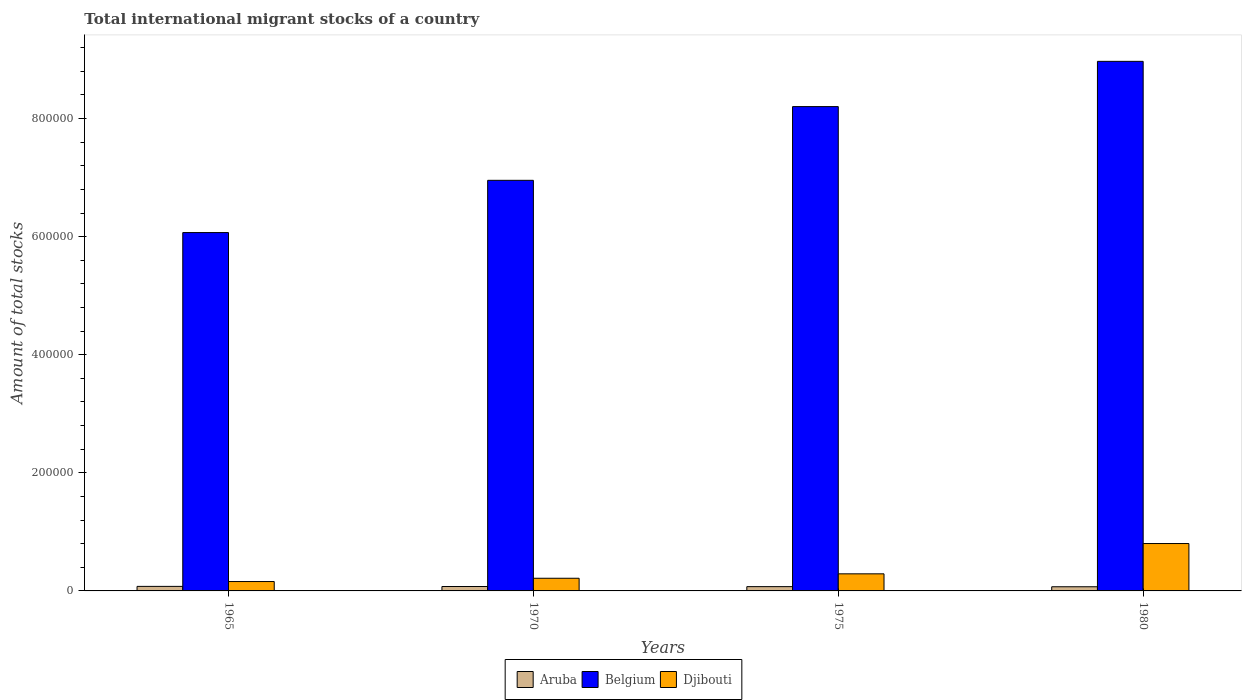Are the number of bars per tick equal to the number of legend labels?
Ensure brevity in your answer.  Yes. Are the number of bars on each tick of the X-axis equal?
Your answer should be very brief. Yes. In how many cases, is the number of bars for a given year not equal to the number of legend labels?
Make the answer very short. 0. What is the amount of total stocks in in Belgium in 1965?
Your answer should be very brief. 6.07e+05. Across all years, what is the maximum amount of total stocks in in Belgium?
Your response must be concise. 8.97e+05. Across all years, what is the minimum amount of total stocks in in Djibouti?
Your response must be concise. 1.59e+04. In which year was the amount of total stocks in in Aruba maximum?
Give a very brief answer. 1965. In which year was the amount of total stocks in in Aruba minimum?
Offer a terse response. 1980. What is the total amount of total stocks in in Djibouti in the graph?
Provide a short and direct response. 1.46e+05. What is the difference between the amount of total stocks in in Belgium in 1965 and that in 1980?
Your answer should be very brief. -2.90e+05. What is the difference between the amount of total stocks in in Belgium in 1965 and the amount of total stocks in in Djibouti in 1970?
Your answer should be compact. 5.85e+05. What is the average amount of total stocks in in Aruba per year?
Provide a succinct answer. 7367. In the year 1965, what is the difference between the amount of total stocks in in Belgium and amount of total stocks in in Aruba?
Make the answer very short. 5.99e+05. What is the ratio of the amount of total stocks in in Djibouti in 1965 to that in 1975?
Provide a short and direct response. 0.55. Is the amount of total stocks in in Belgium in 1970 less than that in 1975?
Keep it short and to the point. Yes. What is the difference between the highest and the second highest amount of total stocks in in Djibouti?
Ensure brevity in your answer.  5.13e+04. What is the difference between the highest and the lowest amount of total stocks in in Aruba?
Ensure brevity in your answer.  614. Is the sum of the amount of total stocks in in Belgium in 1965 and 1970 greater than the maximum amount of total stocks in in Aruba across all years?
Keep it short and to the point. Yes. What does the 3rd bar from the left in 1965 represents?
Offer a terse response. Djibouti. How many bars are there?
Give a very brief answer. 12. How many years are there in the graph?
Provide a succinct answer. 4. Does the graph contain grids?
Offer a very short reply. No. Where does the legend appear in the graph?
Offer a very short reply. Bottom center. How many legend labels are there?
Provide a succinct answer. 3. What is the title of the graph?
Your response must be concise. Total international migrant stocks of a country. Does "Other small states" appear as one of the legend labels in the graph?
Ensure brevity in your answer.  No. What is the label or title of the X-axis?
Provide a short and direct response. Years. What is the label or title of the Y-axis?
Ensure brevity in your answer.  Amount of total stocks. What is the Amount of total stocks in Aruba in 1965?
Ensure brevity in your answer.  7677. What is the Amount of total stocks of Belgium in 1965?
Your answer should be compact. 6.07e+05. What is the Amount of total stocks of Djibouti in 1965?
Your response must be concise. 1.59e+04. What is the Amount of total stocks in Aruba in 1970?
Give a very brief answer. 7466. What is the Amount of total stocks in Belgium in 1970?
Your response must be concise. 6.95e+05. What is the Amount of total stocks in Djibouti in 1970?
Your answer should be compact. 2.14e+04. What is the Amount of total stocks in Aruba in 1975?
Provide a succinct answer. 7262. What is the Amount of total stocks of Belgium in 1975?
Make the answer very short. 8.20e+05. What is the Amount of total stocks in Djibouti in 1975?
Your response must be concise. 2.89e+04. What is the Amount of total stocks in Aruba in 1980?
Keep it short and to the point. 7063. What is the Amount of total stocks in Belgium in 1980?
Ensure brevity in your answer.  8.97e+05. What is the Amount of total stocks of Djibouti in 1980?
Offer a very short reply. 8.02e+04. Across all years, what is the maximum Amount of total stocks of Aruba?
Provide a succinct answer. 7677. Across all years, what is the maximum Amount of total stocks in Belgium?
Ensure brevity in your answer.  8.97e+05. Across all years, what is the maximum Amount of total stocks of Djibouti?
Give a very brief answer. 8.02e+04. Across all years, what is the minimum Amount of total stocks of Aruba?
Your answer should be compact. 7063. Across all years, what is the minimum Amount of total stocks in Belgium?
Provide a short and direct response. 6.07e+05. Across all years, what is the minimum Amount of total stocks in Djibouti?
Provide a short and direct response. 1.59e+04. What is the total Amount of total stocks in Aruba in the graph?
Your answer should be compact. 2.95e+04. What is the total Amount of total stocks in Belgium in the graph?
Make the answer very short. 3.02e+06. What is the total Amount of total stocks in Djibouti in the graph?
Provide a succinct answer. 1.46e+05. What is the difference between the Amount of total stocks in Aruba in 1965 and that in 1970?
Offer a terse response. 211. What is the difference between the Amount of total stocks in Belgium in 1965 and that in 1970?
Give a very brief answer. -8.85e+04. What is the difference between the Amount of total stocks in Djibouti in 1965 and that in 1970?
Ensure brevity in your answer.  -5557. What is the difference between the Amount of total stocks of Aruba in 1965 and that in 1975?
Provide a succinct answer. 415. What is the difference between the Amount of total stocks in Belgium in 1965 and that in 1975?
Offer a terse response. -2.13e+05. What is the difference between the Amount of total stocks of Djibouti in 1965 and that in 1975?
Give a very brief answer. -1.31e+04. What is the difference between the Amount of total stocks of Aruba in 1965 and that in 1980?
Give a very brief answer. 614. What is the difference between the Amount of total stocks of Belgium in 1965 and that in 1980?
Give a very brief answer. -2.90e+05. What is the difference between the Amount of total stocks of Djibouti in 1965 and that in 1980?
Ensure brevity in your answer.  -6.43e+04. What is the difference between the Amount of total stocks in Aruba in 1970 and that in 1975?
Ensure brevity in your answer.  204. What is the difference between the Amount of total stocks in Belgium in 1970 and that in 1975?
Make the answer very short. -1.25e+05. What is the difference between the Amount of total stocks of Djibouti in 1970 and that in 1975?
Your answer should be compact. -7501. What is the difference between the Amount of total stocks in Aruba in 1970 and that in 1980?
Ensure brevity in your answer.  403. What is the difference between the Amount of total stocks in Belgium in 1970 and that in 1980?
Ensure brevity in your answer.  -2.01e+05. What is the difference between the Amount of total stocks of Djibouti in 1970 and that in 1980?
Offer a very short reply. -5.88e+04. What is the difference between the Amount of total stocks in Aruba in 1975 and that in 1980?
Make the answer very short. 199. What is the difference between the Amount of total stocks in Belgium in 1975 and that in 1980?
Ensure brevity in your answer.  -7.66e+04. What is the difference between the Amount of total stocks of Djibouti in 1975 and that in 1980?
Offer a terse response. -5.13e+04. What is the difference between the Amount of total stocks in Aruba in 1965 and the Amount of total stocks in Belgium in 1970?
Ensure brevity in your answer.  -6.88e+05. What is the difference between the Amount of total stocks of Aruba in 1965 and the Amount of total stocks of Djibouti in 1970?
Your answer should be compact. -1.38e+04. What is the difference between the Amount of total stocks of Belgium in 1965 and the Amount of total stocks of Djibouti in 1970?
Your response must be concise. 5.85e+05. What is the difference between the Amount of total stocks of Aruba in 1965 and the Amount of total stocks of Belgium in 1975?
Provide a succinct answer. -8.13e+05. What is the difference between the Amount of total stocks in Aruba in 1965 and the Amount of total stocks in Djibouti in 1975?
Provide a succinct answer. -2.13e+04. What is the difference between the Amount of total stocks in Belgium in 1965 and the Amount of total stocks in Djibouti in 1975?
Provide a succinct answer. 5.78e+05. What is the difference between the Amount of total stocks in Aruba in 1965 and the Amount of total stocks in Belgium in 1980?
Keep it short and to the point. -8.89e+05. What is the difference between the Amount of total stocks in Aruba in 1965 and the Amount of total stocks in Djibouti in 1980?
Your answer should be compact. -7.26e+04. What is the difference between the Amount of total stocks of Belgium in 1965 and the Amount of total stocks of Djibouti in 1980?
Offer a very short reply. 5.27e+05. What is the difference between the Amount of total stocks in Aruba in 1970 and the Amount of total stocks in Belgium in 1975?
Ensure brevity in your answer.  -8.13e+05. What is the difference between the Amount of total stocks of Aruba in 1970 and the Amount of total stocks of Djibouti in 1975?
Give a very brief answer. -2.15e+04. What is the difference between the Amount of total stocks in Belgium in 1970 and the Amount of total stocks in Djibouti in 1975?
Provide a succinct answer. 6.66e+05. What is the difference between the Amount of total stocks in Aruba in 1970 and the Amount of total stocks in Belgium in 1980?
Your response must be concise. -8.89e+05. What is the difference between the Amount of total stocks in Aruba in 1970 and the Amount of total stocks in Djibouti in 1980?
Give a very brief answer. -7.28e+04. What is the difference between the Amount of total stocks of Belgium in 1970 and the Amount of total stocks of Djibouti in 1980?
Provide a succinct answer. 6.15e+05. What is the difference between the Amount of total stocks in Aruba in 1975 and the Amount of total stocks in Belgium in 1980?
Provide a succinct answer. -8.90e+05. What is the difference between the Amount of total stocks in Aruba in 1975 and the Amount of total stocks in Djibouti in 1980?
Provide a short and direct response. -7.30e+04. What is the difference between the Amount of total stocks of Belgium in 1975 and the Amount of total stocks of Djibouti in 1980?
Your response must be concise. 7.40e+05. What is the average Amount of total stocks of Aruba per year?
Give a very brief answer. 7367. What is the average Amount of total stocks of Belgium per year?
Make the answer very short. 7.55e+05. What is the average Amount of total stocks in Djibouti per year?
Keep it short and to the point. 3.66e+04. In the year 1965, what is the difference between the Amount of total stocks in Aruba and Amount of total stocks in Belgium?
Provide a short and direct response. -5.99e+05. In the year 1965, what is the difference between the Amount of total stocks in Aruba and Amount of total stocks in Djibouti?
Offer a terse response. -8206. In the year 1965, what is the difference between the Amount of total stocks of Belgium and Amount of total stocks of Djibouti?
Offer a terse response. 5.91e+05. In the year 1970, what is the difference between the Amount of total stocks of Aruba and Amount of total stocks of Belgium?
Offer a terse response. -6.88e+05. In the year 1970, what is the difference between the Amount of total stocks of Aruba and Amount of total stocks of Djibouti?
Keep it short and to the point. -1.40e+04. In the year 1970, what is the difference between the Amount of total stocks of Belgium and Amount of total stocks of Djibouti?
Keep it short and to the point. 6.74e+05. In the year 1975, what is the difference between the Amount of total stocks in Aruba and Amount of total stocks in Belgium?
Keep it short and to the point. -8.13e+05. In the year 1975, what is the difference between the Amount of total stocks in Aruba and Amount of total stocks in Djibouti?
Make the answer very short. -2.17e+04. In the year 1975, what is the difference between the Amount of total stocks of Belgium and Amount of total stocks of Djibouti?
Give a very brief answer. 7.91e+05. In the year 1980, what is the difference between the Amount of total stocks in Aruba and Amount of total stocks in Belgium?
Your answer should be compact. -8.90e+05. In the year 1980, what is the difference between the Amount of total stocks in Aruba and Amount of total stocks in Djibouti?
Provide a short and direct response. -7.32e+04. In the year 1980, what is the difference between the Amount of total stocks in Belgium and Amount of total stocks in Djibouti?
Give a very brief answer. 8.17e+05. What is the ratio of the Amount of total stocks in Aruba in 1965 to that in 1970?
Your answer should be very brief. 1.03. What is the ratio of the Amount of total stocks in Belgium in 1965 to that in 1970?
Your answer should be compact. 0.87. What is the ratio of the Amount of total stocks of Djibouti in 1965 to that in 1970?
Provide a short and direct response. 0.74. What is the ratio of the Amount of total stocks in Aruba in 1965 to that in 1975?
Provide a short and direct response. 1.06. What is the ratio of the Amount of total stocks of Belgium in 1965 to that in 1975?
Make the answer very short. 0.74. What is the ratio of the Amount of total stocks in Djibouti in 1965 to that in 1975?
Offer a terse response. 0.55. What is the ratio of the Amount of total stocks in Aruba in 1965 to that in 1980?
Make the answer very short. 1.09. What is the ratio of the Amount of total stocks of Belgium in 1965 to that in 1980?
Ensure brevity in your answer.  0.68. What is the ratio of the Amount of total stocks of Djibouti in 1965 to that in 1980?
Keep it short and to the point. 0.2. What is the ratio of the Amount of total stocks in Aruba in 1970 to that in 1975?
Provide a succinct answer. 1.03. What is the ratio of the Amount of total stocks of Belgium in 1970 to that in 1975?
Make the answer very short. 0.85. What is the ratio of the Amount of total stocks of Djibouti in 1970 to that in 1975?
Your response must be concise. 0.74. What is the ratio of the Amount of total stocks of Aruba in 1970 to that in 1980?
Your response must be concise. 1.06. What is the ratio of the Amount of total stocks in Belgium in 1970 to that in 1980?
Keep it short and to the point. 0.78. What is the ratio of the Amount of total stocks in Djibouti in 1970 to that in 1980?
Provide a short and direct response. 0.27. What is the ratio of the Amount of total stocks of Aruba in 1975 to that in 1980?
Provide a short and direct response. 1.03. What is the ratio of the Amount of total stocks in Belgium in 1975 to that in 1980?
Your answer should be very brief. 0.91. What is the ratio of the Amount of total stocks in Djibouti in 1975 to that in 1980?
Make the answer very short. 0.36. What is the difference between the highest and the second highest Amount of total stocks in Aruba?
Keep it short and to the point. 211. What is the difference between the highest and the second highest Amount of total stocks in Belgium?
Ensure brevity in your answer.  7.66e+04. What is the difference between the highest and the second highest Amount of total stocks of Djibouti?
Provide a succinct answer. 5.13e+04. What is the difference between the highest and the lowest Amount of total stocks in Aruba?
Keep it short and to the point. 614. What is the difference between the highest and the lowest Amount of total stocks in Belgium?
Provide a succinct answer. 2.90e+05. What is the difference between the highest and the lowest Amount of total stocks in Djibouti?
Provide a succinct answer. 6.43e+04. 